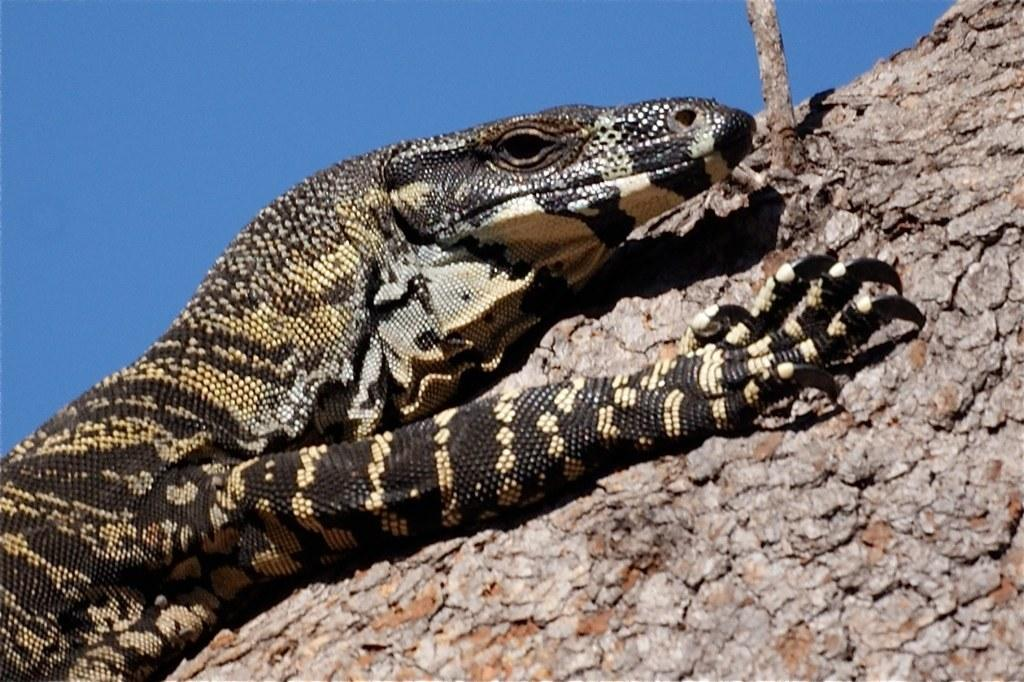What type of animal is in the image? There is a reptile in the image. Where is the reptile located in the image? The reptile is in the front of the image. What is the reptile resting on in the image? The reptile is on a surface that resembles the bark of a tree. What can be seen in the background of the image? The background of the image includes the sky. How many tickets are visible in the image? There are no tickets present in the image. Is the reptile using a light bulb for warmth in the image? There is no light bulb present in the image, and the reptile's source of warmth is not mentioned. 